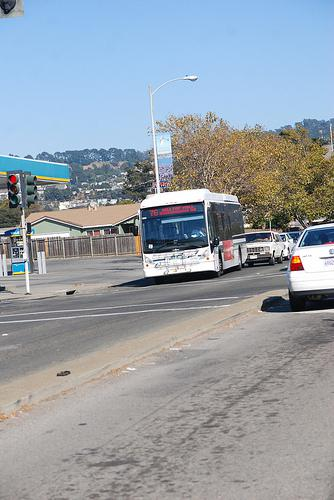Question: what color is the sky in this photo?
Choices:
A. Yellow.
B. Blue.
C. Black.
D. Pink.
Answer with the letter. Answer: B Question: what color is the street light indicating?
Choices:
A. Blue.
B. Red.
C. Brown.
D. Green.
Answer with the letter. Answer: B Question: what number is the bus displaying on its sign?
Choices:
A. 76.
B. 86.
C. 24.
D. 65.
Answer with the letter. Answer: A Question: why are the cars stopped?
Choices:
A. It's a stop sign.
B. Red light.
C. Construction.
D. There is a traffic accident.
Answer with the letter. Answer: B 